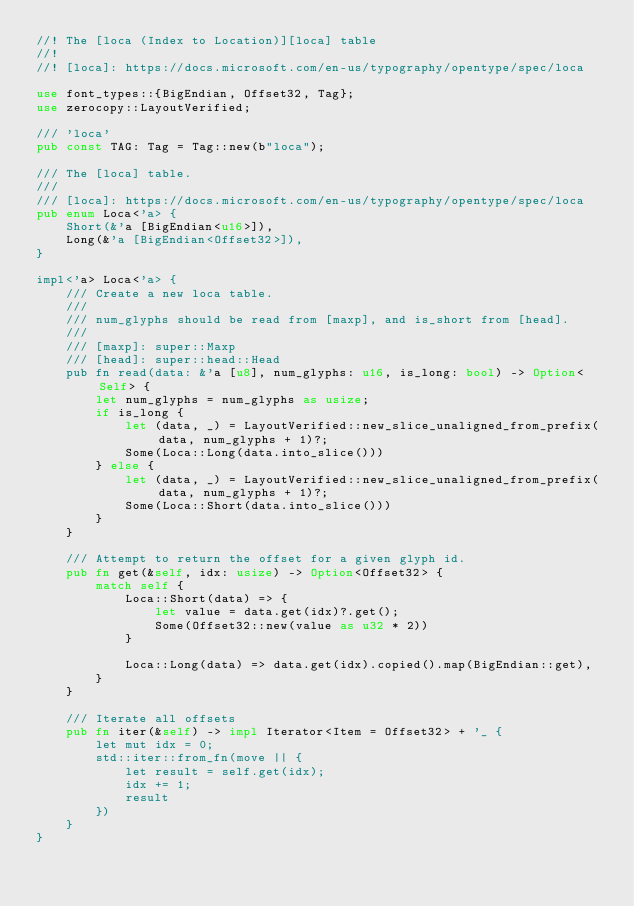Convert code to text. <code><loc_0><loc_0><loc_500><loc_500><_Rust_>//! The [loca (Index to Location)][loca] table
//!
//! [loca]: https://docs.microsoft.com/en-us/typography/opentype/spec/loca

use font_types::{BigEndian, Offset32, Tag};
use zerocopy::LayoutVerified;

/// 'loca'
pub const TAG: Tag = Tag::new(b"loca");

/// The [loca] table.
///
/// [loca]: https://docs.microsoft.com/en-us/typography/opentype/spec/loca
pub enum Loca<'a> {
    Short(&'a [BigEndian<u16>]),
    Long(&'a [BigEndian<Offset32>]),
}

impl<'a> Loca<'a> {
    /// Create a new loca table.
    ///
    /// num_glyphs should be read from [maxp], and is_short from [head].
    ///
    /// [maxp]: super::Maxp
    /// [head]: super::head::Head
    pub fn read(data: &'a [u8], num_glyphs: u16, is_long: bool) -> Option<Self> {
        let num_glyphs = num_glyphs as usize;
        if is_long {
            let (data, _) = LayoutVerified::new_slice_unaligned_from_prefix(data, num_glyphs + 1)?;
            Some(Loca::Long(data.into_slice()))
        } else {
            let (data, _) = LayoutVerified::new_slice_unaligned_from_prefix(data, num_glyphs + 1)?;
            Some(Loca::Short(data.into_slice()))
        }
    }

    /// Attempt to return the offset for a given glyph id.
    pub fn get(&self, idx: usize) -> Option<Offset32> {
        match self {
            Loca::Short(data) => {
                let value = data.get(idx)?.get();
                Some(Offset32::new(value as u32 * 2))
            }

            Loca::Long(data) => data.get(idx).copied().map(BigEndian::get),
        }
    }

    /// Iterate all offsets
    pub fn iter(&self) -> impl Iterator<Item = Offset32> + '_ {
        let mut idx = 0;
        std::iter::from_fn(move || {
            let result = self.get(idx);
            idx += 1;
            result
        })
    }
}
</code> 